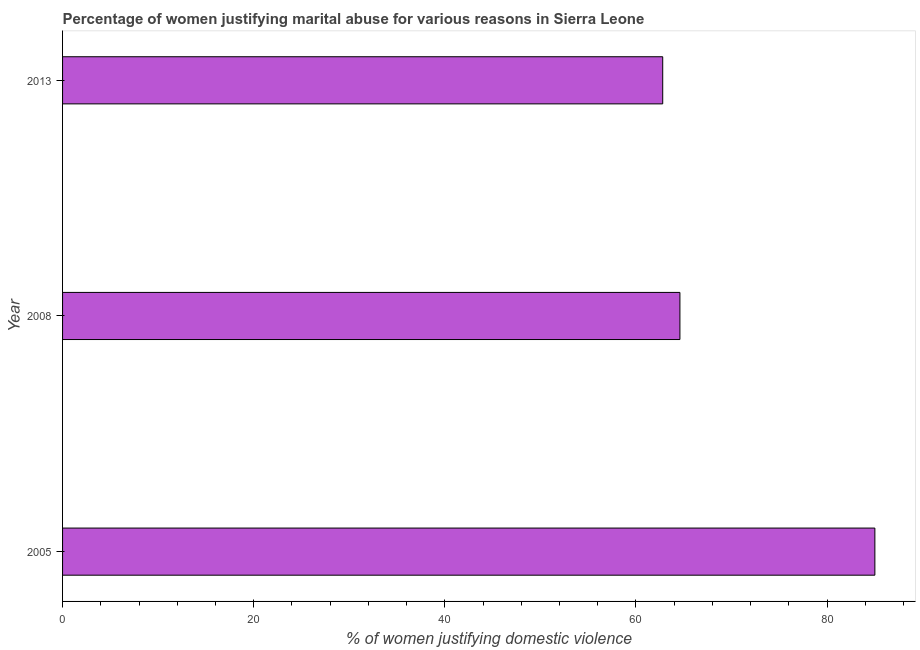Does the graph contain grids?
Provide a succinct answer. No. What is the title of the graph?
Your response must be concise. Percentage of women justifying marital abuse for various reasons in Sierra Leone. What is the label or title of the X-axis?
Offer a very short reply. % of women justifying domestic violence. What is the percentage of women justifying marital abuse in 2008?
Ensure brevity in your answer.  64.6. Across all years, what is the maximum percentage of women justifying marital abuse?
Offer a very short reply. 85. Across all years, what is the minimum percentage of women justifying marital abuse?
Provide a short and direct response. 62.8. In which year was the percentage of women justifying marital abuse minimum?
Your response must be concise. 2013. What is the sum of the percentage of women justifying marital abuse?
Your answer should be very brief. 212.4. What is the average percentage of women justifying marital abuse per year?
Make the answer very short. 70.8. What is the median percentage of women justifying marital abuse?
Offer a very short reply. 64.6. Do a majority of the years between 2008 and 2013 (inclusive) have percentage of women justifying marital abuse greater than 16 %?
Your answer should be very brief. Yes. What is the ratio of the percentage of women justifying marital abuse in 2005 to that in 2013?
Give a very brief answer. 1.35. What is the difference between the highest and the second highest percentage of women justifying marital abuse?
Provide a short and direct response. 20.4. What is the difference between the highest and the lowest percentage of women justifying marital abuse?
Keep it short and to the point. 22.2. In how many years, is the percentage of women justifying marital abuse greater than the average percentage of women justifying marital abuse taken over all years?
Keep it short and to the point. 1. How many bars are there?
Provide a succinct answer. 3. How many years are there in the graph?
Provide a short and direct response. 3. Are the values on the major ticks of X-axis written in scientific E-notation?
Provide a succinct answer. No. What is the % of women justifying domestic violence of 2005?
Your response must be concise. 85. What is the % of women justifying domestic violence of 2008?
Offer a terse response. 64.6. What is the % of women justifying domestic violence in 2013?
Offer a very short reply. 62.8. What is the difference between the % of women justifying domestic violence in 2005 and 2008?
Keep it short and to the point. 20.4. What is the ratio of the % of women justifying domestic violence in 2005 to that in 2008?
Offer a very short reply. 1.32. What is the ratio of the % of women justifying domestic violence in 2005 to that in 2013?
Give a very brief answer. 1.35. What is the ratio of the % of women justifying domestic violence in 2008 to that in 2013?
Keep it short and to the point. 1.03. 